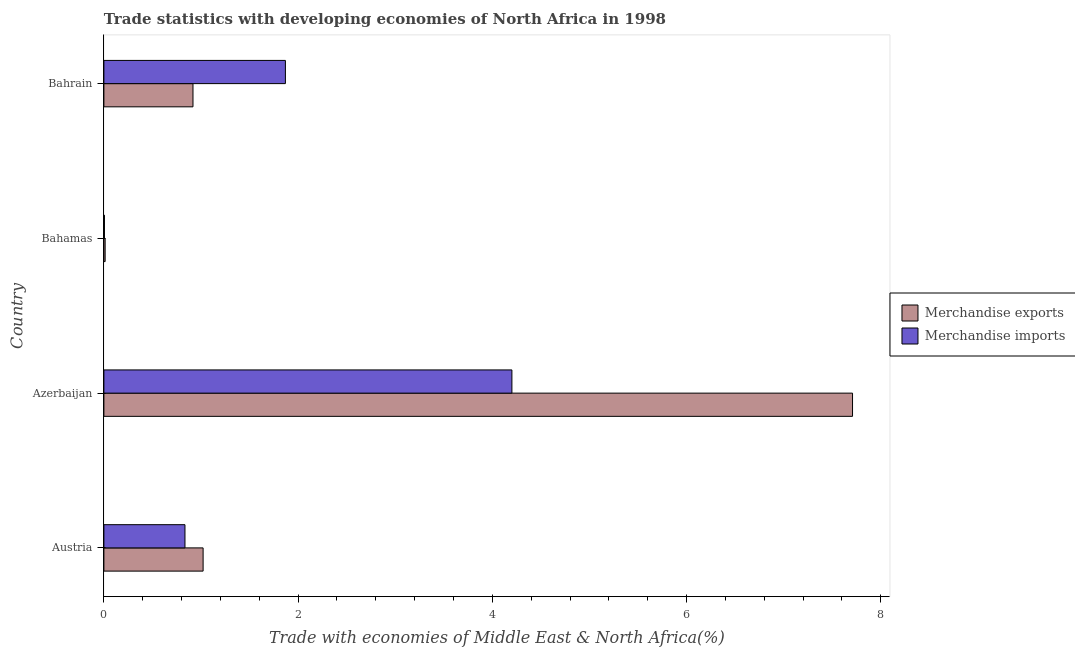Are the number of bars per tick equal to the number of legend labels?
Offer a very short reply. Yes. What is the label of the 2nd group of bars from the top?
Make the answer very short. Bahamas. What is the merchandise imports in Bahamas?
Keep it short and to the point. 0.01. Across all countries, what is the maximum merchandise exports?
Your answer should be compact. 7.71. Across all countries, what is the minimum merchandise exports?
Give a very brief answer. 0.01. In which country was the merchandise exports maximum?
Keep it short and to the point. Azerbaijan. In which country was the merchandise imports minimum?
Your answer should be compact. Bahamas. What is the total merchandise imports in the graph?
Ensure brevity in your answer.  6.91. What is the difference between the merchandise imports in Azerbaijan and that in Bahrain?
Provide a short and direct response. 2.33. What is the difference between the merchandise exports in Bahrain and the merchandise imports in Bahamas?
Make the answer very short. 0.91. What is the average merchandise exports per country?
Provide a short and direct response. 2.42. What is the ratio of the merchandise exports in Austria to that in Azerbaijan?
Your answer should be compact. 0.13. What is the difference between the highest and the second highest merchandise imports?
Provide a succinct answer. 2.33. What is the difference between the highest and the lowest merchandise exports?
Make the answer very short. 7.7. Is the sum of the merchandise imports in Bahamas and Bahrain greater than the maximum merchandise exports across all countries?
Give a very brief answer. No. What does the 2nd bar from the bottom in Austria represents?
Your answer should be compact. Merchandise imports. How many bars are there?
Keep it short and to the point. 8. What is the difference between two consecutive major ticks on the X-axis?
Ensure brevity in your answer.  2. Are the values on the major ticks of X-axis written in scientific E-notation?
Your answer should be very brief. No. Does the graph contain any zero values?
Provide a short and direct response. No. How many legend labels are there?
Your answer should be very brief. 2. What is the title of the graph?
Provide a short and direct response. Trade statistics with developing economies of North Africa in 1998. Does "Ages 15-24" appear as one of the legend labels in the graph?
Your answer should be very brief. No. What is the label or title of the X-axis?
Make the answer very short. Trade with economies of Middle East & North Africa(%). What is the label or title of the Y-axis?
Ensure brevity in your answer.  Country. What is the Trade with economies of Middle East & North Africa(%) in Merchandise exports in Austria?
Offer a very short reply. 1.02. What is the Trade with economies of Middle East & North Africa(%) in Merchandise imports in Austria?
Offer a terse response. 0.83. What is the Trade with economies of Middle East & North Africa(%) of Merchandise exports in Azerbaijan?
Keep it short and to the point. 7.71. What is the Trade with economies of Middle East & North Africa(%) of Merchandise imports in Azerbaijan?
Your answer should be very brief. 4.2. What is the Trade with economies of Middle East & North Africa(%) in Merchandise exports in Bahamas?
Your answer should be very brief. 0.01. What is the Trade with economies of Middle East & North Africa(%) of Merchandise imports in Bahamas?
Make the answer very short. 0.01. What is the Trade with economies of Middle East & North Africa(%) of Merchandise exports in Bahrain?
Provide a succinct answer. 0.92. What is the Trade with economies of Middle East & North Africa(%) in Merchandise imports in Bahrain?
Provide a short and direct response. 1.87. Across all countries, what is the maximum Trade with economies of Middle East & North Africa(%) of Merchandise exports?
Your answer should be compact. 7.71. Across all countries, what is the maximum Trade with economies of Middle East & North Africa(%) in Merchandise imports?
Ensure brevity in your answer.  4.2. Across all countries, what is the minimum Trade with economies of Middle East & North Africa(%) of Merchandise exports?
Make the answer very short. 0.01. Across all countries, what is the minimum Trade with economies of Middle East & North Africa(%) in Merchandise imports?
Keep it short and to the point. 0.01. What is the total Trade with economies of Middle East & North Africa(%) in Merchandise exports in the graph?
Make the answer very short. 9.66. What is the total Trade with economies of Middle East & North Africa(%) in Merchandise imports in the graph?
Your answer should be very brief. 6.91. What is the difference between the Trade with economies of Middle East & North Africa(%) of Merchandise exports in Austria and that in Azerbaijan?
Your response must be concise. -6.69. What is the difference between the Trade with economies of Middle East & North Africa(%) of Merchandise imports in Austria and that in Azerbaijan?
Keep it short and to the point. -3.37. What is the difference between the Trade with economies of Middle East & North Africa(%) of Merchandise exports in Austria and that in Bahamas?
Your answer should be compact. 1.01. What is the difference between the Trade with economies of Middle East & North Africa(%) in Merchandise imports in Austria and that in Bahamas?
Your answer should be very brief. 0.83. What is the difference between the Trade with economies of Middle East & North Africa(%) of Merchandise exports in Austria and that in Bahrain?
Offer a very short reply. 0.1. What is the difference between the Trade with economies of Middle East & North Africa(%) in Merchandise imports in Austria and that in Bahrain?
Make the answer very short. -1.03. What is the difference between the Trade with economies of Middle East & North Africa(%) in Merchandise exports in Azerbaijan and that in Bahamas?
Make the answer very short. 7.7. What is the difference between the Trade with economies of Middle East & North Africa(%) in Merchandise imports in Azerbaijan and that in Bahamas?
Give a very brief answer. 4.2. What is the difference between the Trade with economies of Middle East & North Africa(%) in Merchandise exports in Azerbaijan and that in Bahrain?
Your answer should be compact. 6.79. What is the difference between the Trade with economies of Middle East & North Africa(%) in Merchandise imports in Azerbaijan and that in Bahrain?
Offer a terse response. 2.33. What is the difference between the Trade with economies of Middle East & North Africa(%) of Merchandise exports in Bahamas and that in Bahrain?
Give a very brief answer. -0.9. What is the difference between the Trade with economies of Middle East & North Africa(%) in Merchandise imports in Bahamas and that in Bahrain?
Offer a terse response. -1.86. What is the difference between the Trade with economies of Middle East & North Africa(%) in Merchandise exports in Austria and the Trade with economies of Middle East & North Africa(%) in Merchandise imports in Azerbaijan?
Make the answer very short. -3.18. What is the difference between the Trade with economies of Middle East & North Africa(%) of Merchandise exports in Austria and the Trade with economies of Middle East & North Africa(%) of Merchandise imports in Bahrain?
Make the answer very short. -0.85. What is the difference between the Trade with economies of Middle East & North Africa(%) of Merchandise exports in Azerbaijan and the Trade with economies of Middle East & North Africa(%) of Merchandise imports in Bahamas?
Give a very brief answer. 7.7. What is the difference between the Trade with economies of Middle East & North Africa(%) of Merchandise exports in Azerbaijan and the Trade with economies of Middle East & North Africa(%) of Merchandise imports in Bahrain?
Keep it short and to the point. 5.84. What is the difference between the Trade with economies of Middle East & North Africa(%) in Merchandise exports in Bahamas and the Trade with economies of Middle East & North Africa(%) in Merchandise imports in Bahrain?
Offer a terse response. -1.86. What is the average Trade with economies of Middle East & North Africa(%) in Merchandise exports per country?
Make the answer very short. 2.42. What is the average Trade with economies of Middle East & North Africa(%) in Merchandise imports per country?
Your response must be concise. 1.73. What is the difference between the Trade with economies of Middle East & North Africa(%) in Merchandise exports and Trade with economies of Middle East & North Africa(%) in Merchandise imports in Austria?
Offer a very short reply. 0.19. What is the difference between the Trade with economies of Middle East & North Africa(%) of Merchandise exports and Trade with economies of Middle East & North Africa(%) of Merchandise imports in Azerbaijan?
Ensure brevity in your answer.  3.51. What is the difference between the Trade with economies of Middle East & North Africa(%) in Merchandise exports and Trade with economies of Middle East & North Africa(%) in Merchandise imports in Bahamas?
Your answer should be very brief. 0.01. What is the difference between the Trade with economies of Middle East & North Africa(%) in Merchandise exports and Trade with economies of Middle East & North Africa(%) in Merchandise imports in Bahrain?
Offer a very short reply. -0.95. What is the ratio of the Trade with economies of Middle East & North Africa(%) in Merchandise exports in Austria to that in Azerbaijan?
Make the answer very short. 0.13. What is the ratio of the Trade with economies of Middle East & North Africa(%) in Merchandise imports in Austria to that in Azerbaijan?
Your answer should be compact. 0.2. What is the ratio of the Trade with economies of Middle East & North Africa(%) in Merchandise exports in Austria to that in Bahamas?
Provide a succinct answer. 79.74. What is the ratio of the Trade with economies of Middle East & North Africa(%) in Merchandise imports in Austria to that in Bahamas?
Offer a terse response. 144.36. What is the ratio of the Trade with economies of Middle East & North Africa(%) in Merchandise exports in Austria to that in Bahrain?
Your response must be concise. 1.11. What is the ratio of the Trade with economies of Middle East & North Africa(%) in Merchandise imports in Austria to that in Bahrain?
Make the answer very short. 0.45. What is the ratio of the Trade with economies of Middle East & North Africa(%) of Merchandise exports in Azerbaijan to that in Bahamas?
Ensure brevity in your answer.  601.67. What is the ratio of the Trade with economies of Middle East & North Africa(%) in Merchandise imports in Azerbaijan to that in Bahamas?
Your response must be concise. 726.43. What is the ratio of the Trade with economies of Middle East & North Africa(%) in Merchandise exports in Azerbaijan to that in Bahrain?
Make the answer very short. 8.4. What is the ratio of the Trade with economies of Middle East & North Africa(%) in Merchandise imports in Azerbaijan to that in Bahrain?
Offer a terse response. 2.25. What is the ratio of the Trade with economies of Middle East & North Africa(%) of Merchandise exports in Bahamas to that in Bahrain?
Offer a terse response. 0.01. What is the ratio of the Trade with economies of Middle East & North Africa(%) in Merchandise imports in Bahamas to that in Bahrain?
Ensure brevity in your answer.  0. What is the difference between the highest and the second highest Trade with economies of Middle East & North Africa(%) of Merchandise exports?
Offer a very short reply. 6.69. What is the difference between the highest and the second highest Trade with economies of Middle East & North Africa(%) in Merchandise imports?
Make the answer very short. 2.33. What is the difference between the highest and the lowest Trade with economies of Middle East & North Africa(%) in Merchandise exports?
Provide a succinct answer. 7.7. What is the difference between the highest and the lowest Trade with economies of Middle East & North Africa(%) in Merchandise imports?
Give a very brief answer. 4.2. 